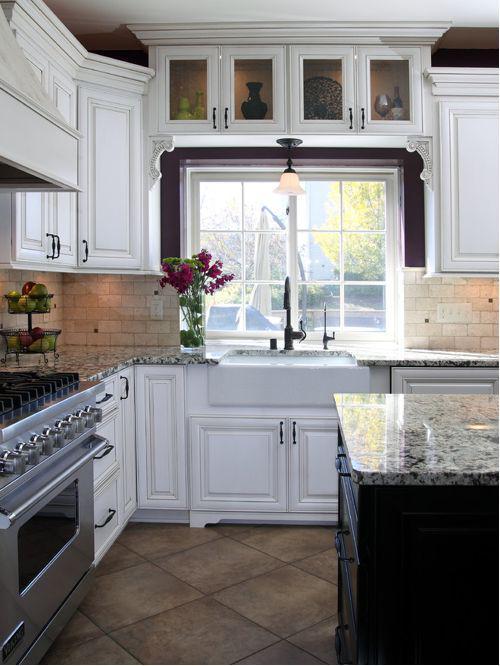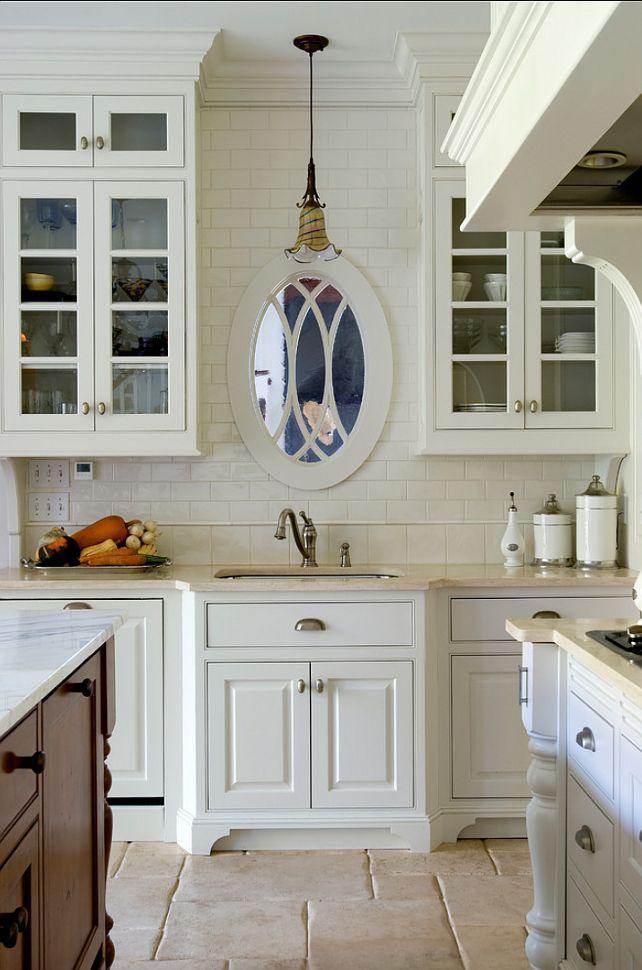The first image is the image on the left, the second image is the image on the right. Assess this claim about the two images: "One kitchen has something decorative above and behind the sink, instead of a window to the outdoors.". Correct or not? Answer yes or no. Yes. The first image is the image on the left, the second image is the image on the right. For the images shown, is this caption "A vase sits to the left of a sink with a window behind it." true? Answer yes or no. Yes. 